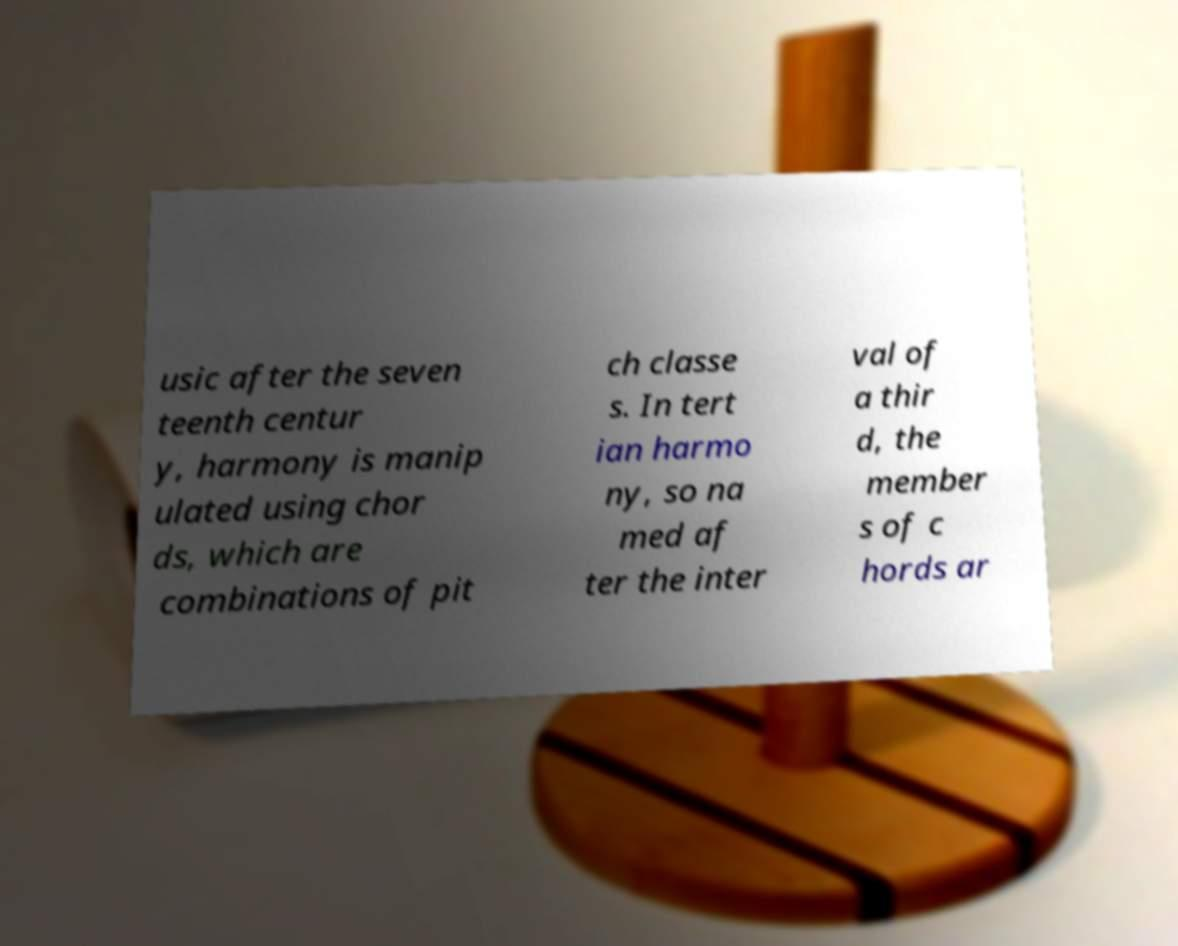Can you read and provide the text displayed in the image?This photo seems to have some interesting text. Can you extract and type it out for me? usic after the seven teenth centur y, harmony is manip ulated using chor ds, which are combinations of pit ch classe s. In tert ian harmo ny, so na med af ter the inter val of a thir d, the member s of c hords ar 